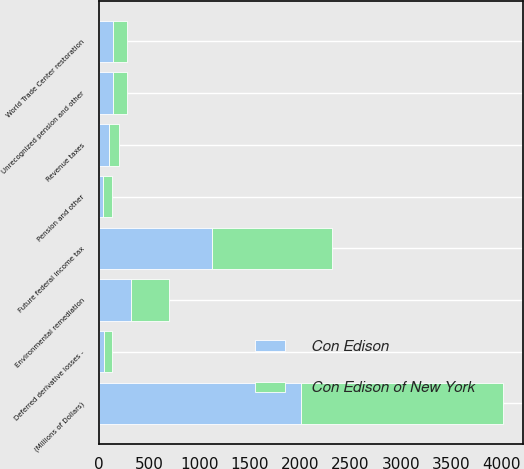<chart> <loc_0><loc_0><loc_500><loc_500><stacked_bar_chart><ecel><fcel>(Millions of Dollars)<fcel>Unrecognized pension and other<fcel>Future federal income tax<fcel>Environmental remediation<fcel>World Trade Center restoration<fcel>Revenue taxes<fcel>Pension and other<fcel>Deferred derivative losses -<nl><fcel>Con Edison of New York<fcel>2008<fcel>140<fcel>1186<fcel>378<fcel>140<fcel>101<fcel>92<fcel>80<nl><fcel>Con Edison<fcel>2008<fcel>140<fcel>1127<fcel>315<fcel>140<fcel>98<fcel>37<fcel>54<nl></chart> 